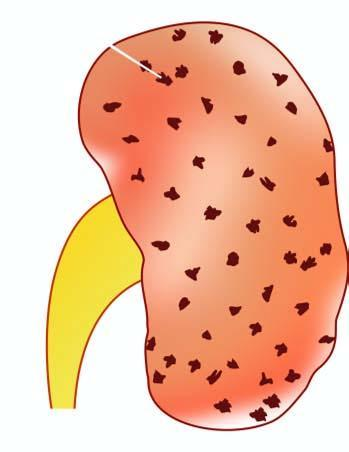what is the kidney enlarged in?
Answer the question using a single word or phrase. Size and weight 